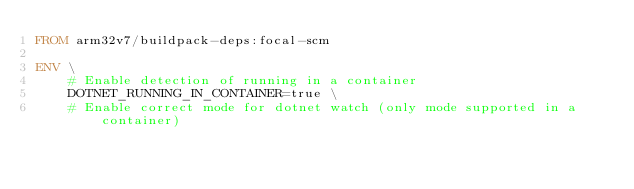Convert code to text. <code><loc_0><loc_0><loc_500><loc_500><_Dockerfile_>FROM arm32v7/buildpack-deps:focal-scm

ENV \
    # Enable detection of running in a container
    DOTNET_RUNNING_IN_CONTAINER=true \
    # Enable correct mode for dotnet watch (only mode supported in a container)</code> 